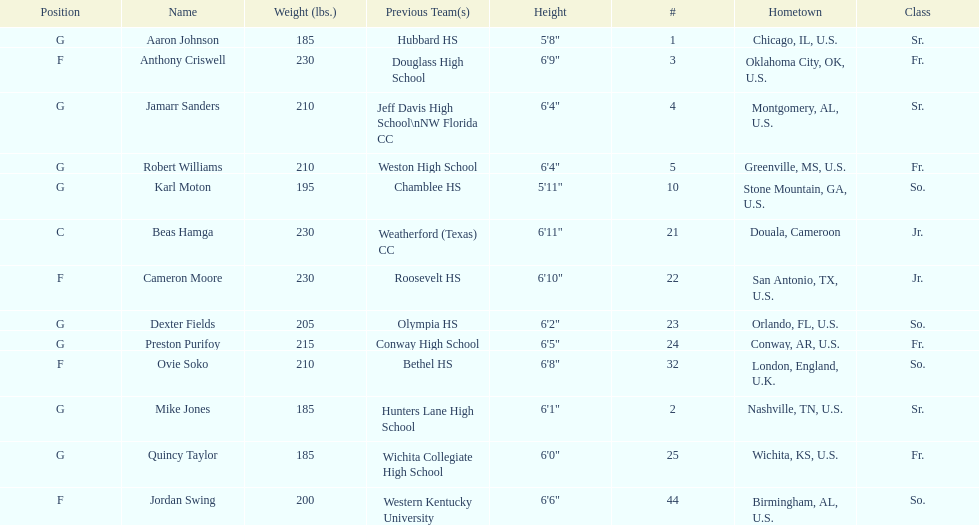Who is first on the roster? Aaron Johnson. 